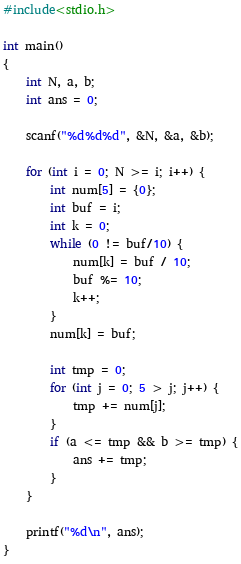Convert code to text. <code><loc_0><loc_0><loc_500><loc_500><_C_>#include<stdio.h>

int main()
{
    int N, a, b;
    int ans = 0;

    scanf("%d%d%d", &N, &a, &b);

    for (int i = 0; N >= i; i++) {
        int num[5] = {0};
        int buf = i;
        int k = 0;
        while (0 != buf/10) {
            num[k] = buf / 10;
            buf %= 10;
            k++;
        }
        num[k] = buf;

        int tmp = 0;
        for (int j = 0; 5 > j; j++) {
            tmp += num[j];
        }
        if (a <= tmp && b >= tmp) {
            ans += tmp;
        }
    }

    printf("%d\n", ans);
}</code> 